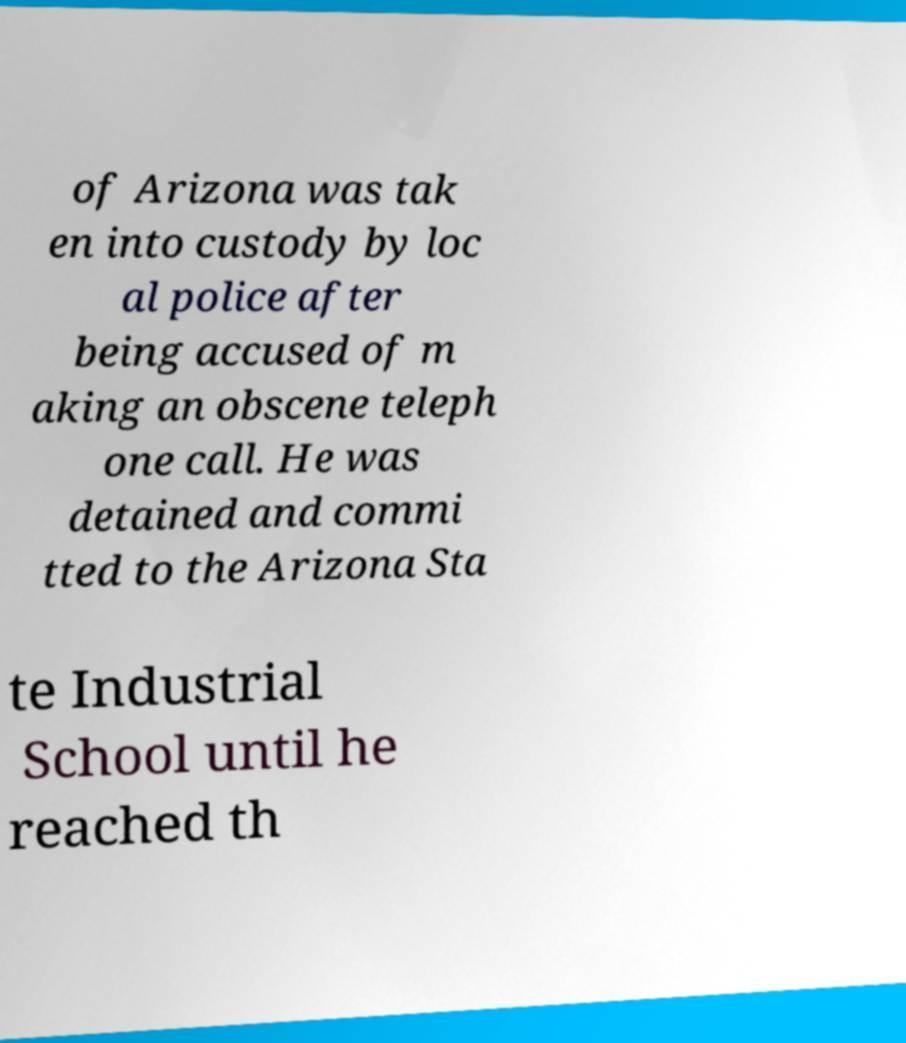For documentation purposes, I need the text within this image transcribed. Could you provide that? of Arizona was tak en into custody by loc al police after being accused of m aking an obscene teleph one call. He was detained and commi tted to the Arizona Sta te Industrial School until he reached th 